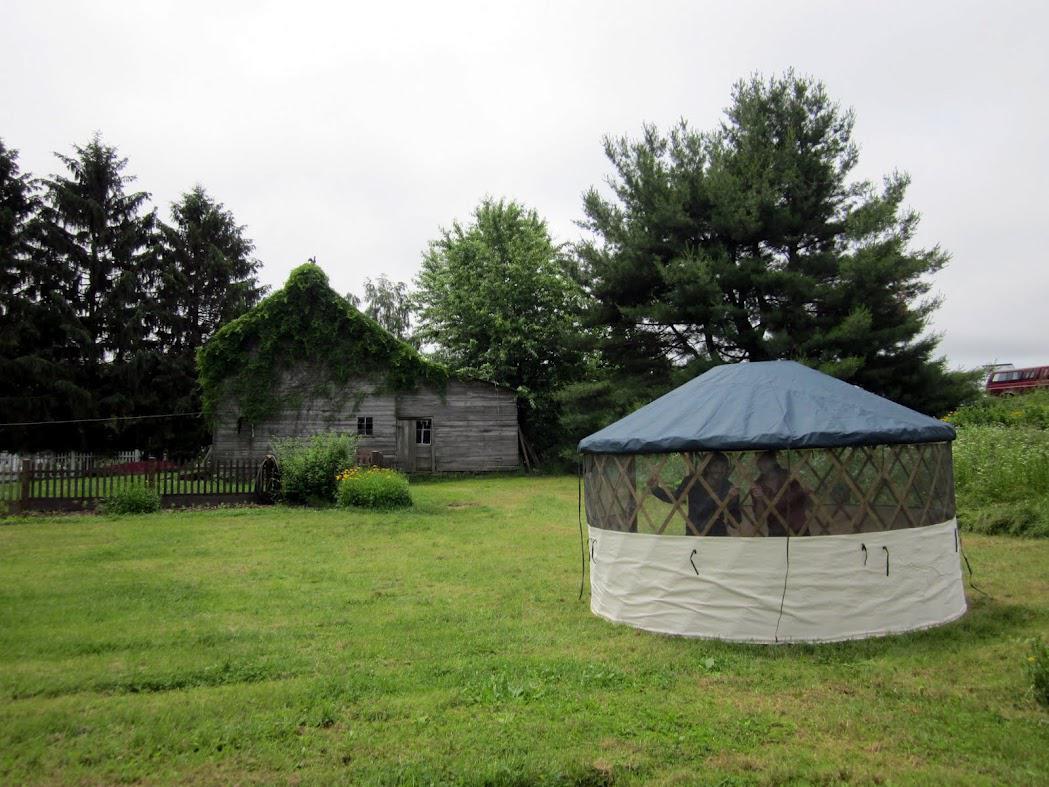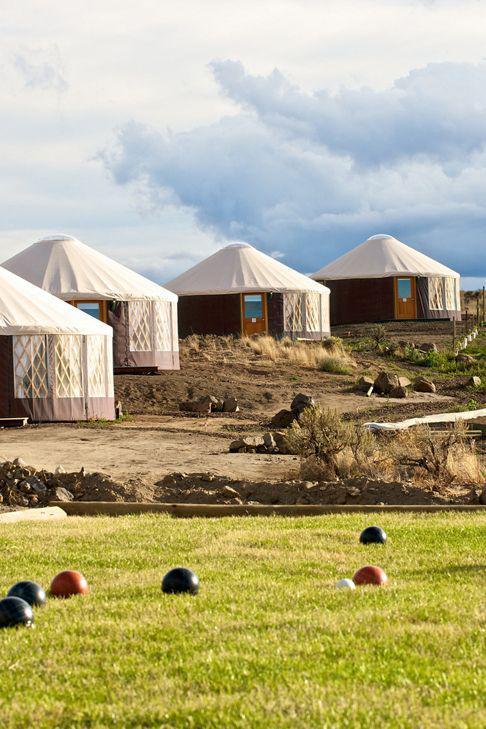The first image is the image on the left, the second image is the image on the right. Assess this claim about the two images: "Exactly three round house structures are shown.". Correct or not? Answer yes or no. No. The first image is the image on the left, the second image is the image on the right. Examine the images to the left and right. Is the description "An image includes at least four cone-topped tents in a row." accurate? Answer yes or no. Yes. 